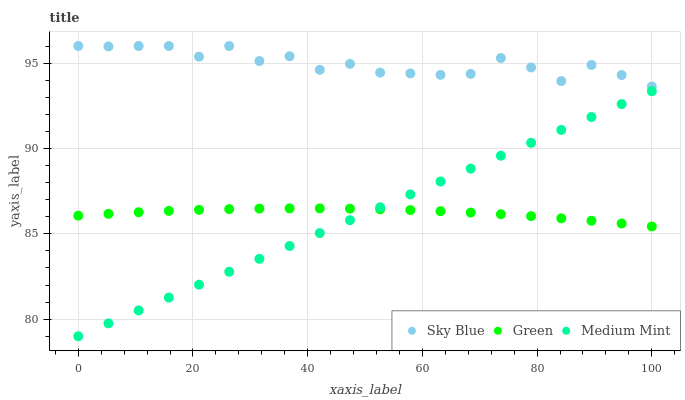Does Medium Mint have the minimum area under the curve?
Answer yes or no. Yes. Does Sky Blue have the maximum area under the curve?
Answer yes or no. Yes. Does Green have the minimum area under the curve?
Answer yes or no. No. Does Green have the maximum area under the curve?
Answer yes or no. No. Is Medium Mint the smoothest?
Answer yes or no. Yes. Is Sky Blue the roughest?
Answer yes or no. Yes. Is Green the smoothest?
Answer yes or no. No. Is Green the roughest?
Answer yes or no. No. Does Medium Mint have the lowest value?
Answer yes or no. Yes. Does Green have the lowest value?
Answer yes or no. No. Does Sky Blue have the highest value?
Answer yes or no. Yes. Does Green have the highest value?
Answer yes or no. No. Is Medium Mint less than Sky Blue?
Answer yes or no. Yes. Is Sky Blue greater than Green?
Answer yes or no. Yes. Does Medium Mint intersect Green?
Answer yes or no. Yes. Is Medium Mint less than Green?
Answer yes or no. No. Is Medium Mint greater than Green?
Answer yes or no. No. Does Medium Mint intersect Sky Blue?
Answer yes or no. No. 